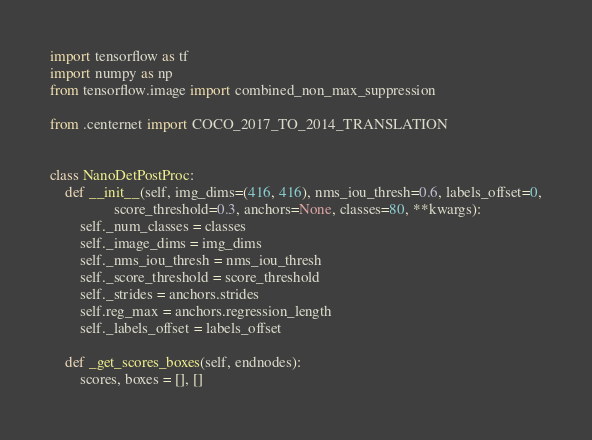<code> <loc_0><loc_0><loc_500><loc_500><_Python_>import tensorflow as tf
import numpy as np
from tensorflow.image import combined_non_max_suppression

from .centernet import COCO_2017_TO_2014_TRANSLATION


class NanoDetPostProc:
    def __init__(self, img_dims=(416, 416), nms_iou_thresh=0.6, labels_offset=0,
                 score_threshold=0.3, anchors=None, classes=80, **kwargs):
        self._num_classes = classes
        self._image_dims = img_dims
        self._nms_iou_thresh = nms_iou_thresh
        self._score_threshold = score_threshold
        self._strides = anchors.strides
        self.reg_max = anchors.regression_length
        self._labels_offset = labels_offset

    def _get_scores_boxes(self, endnodes):
        scores, boxes = [], []</code> 